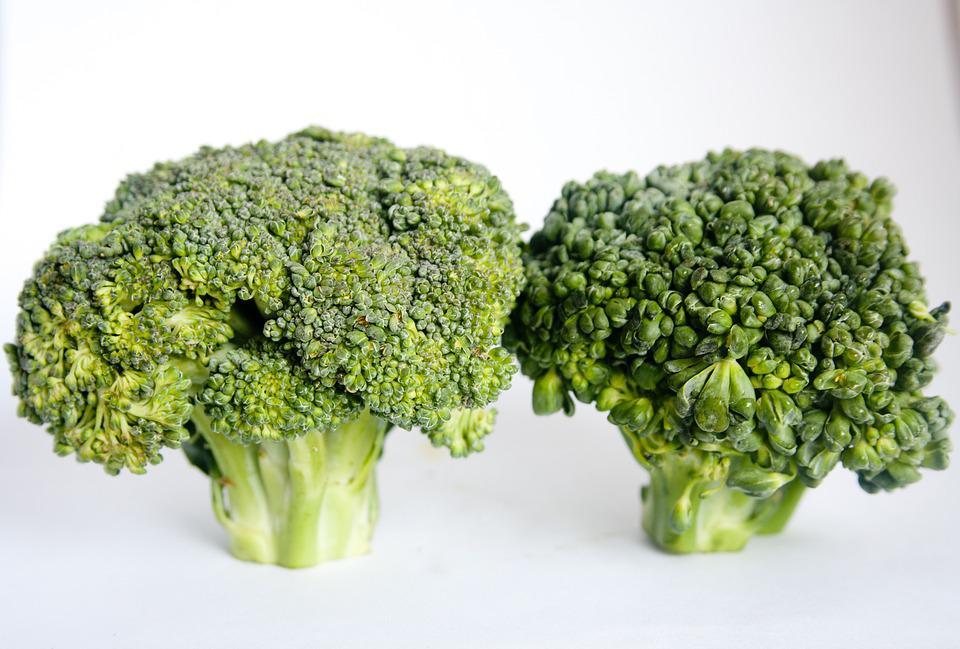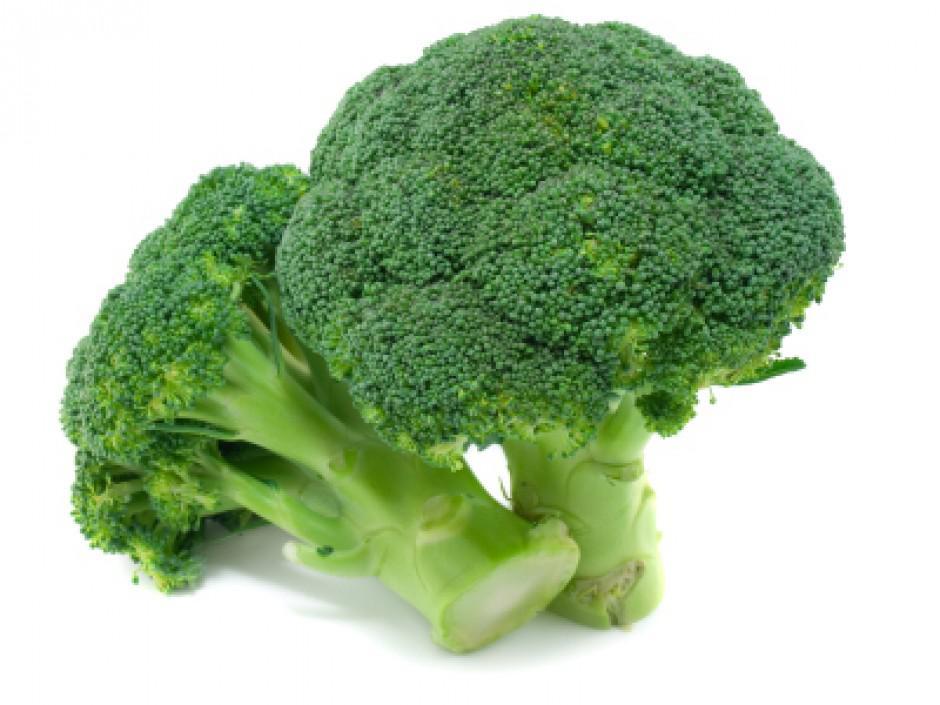The first image is the image on the left, the second image is the image on the right. For the images displayed, is the sentence "A bowl of just broccoli sits on a table with some broccoli pieces around it." factually correct? Answer yes or no. No. The first image is the image on the left, the second image is the image on the right. For the images displayed, is the sentence "There is exactly one bowl of broccoli." factually correct? Answer yes or no. No. 